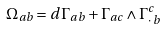<formula> <loc_0><loc_0><loc_500><loc_500>\Omega _ { a b } = d \Gamma _ { a b } + \Gamma _ { a c } \wedge \Gamma ^ { c } _ { \cdot \, b }</formula> 